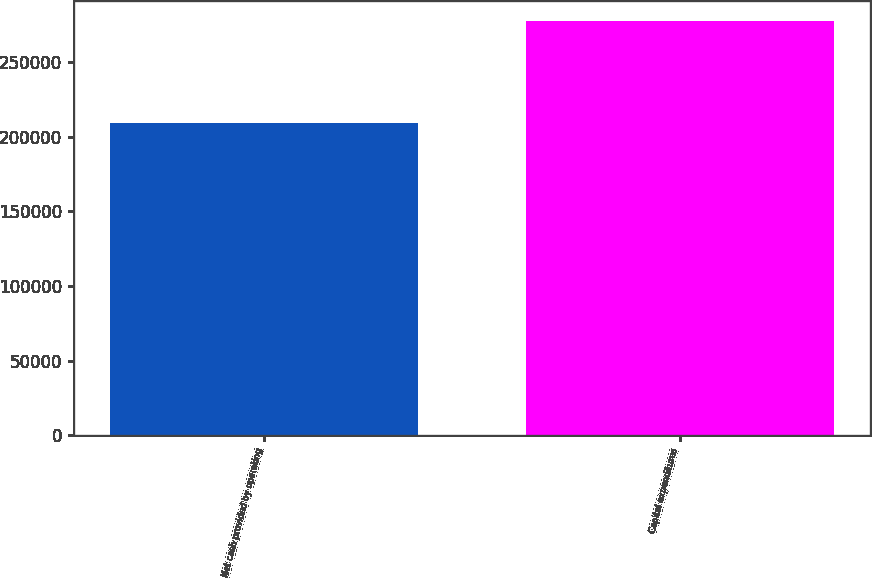Convert chart to OTSL. <chart><loc_0><loc_0><loc_500><loc_500><bar_chart><fcel>Net cash provided by operating<fcel>Capital expenditures<nl><fcel>208932<fcel>277262<nl></chart> 